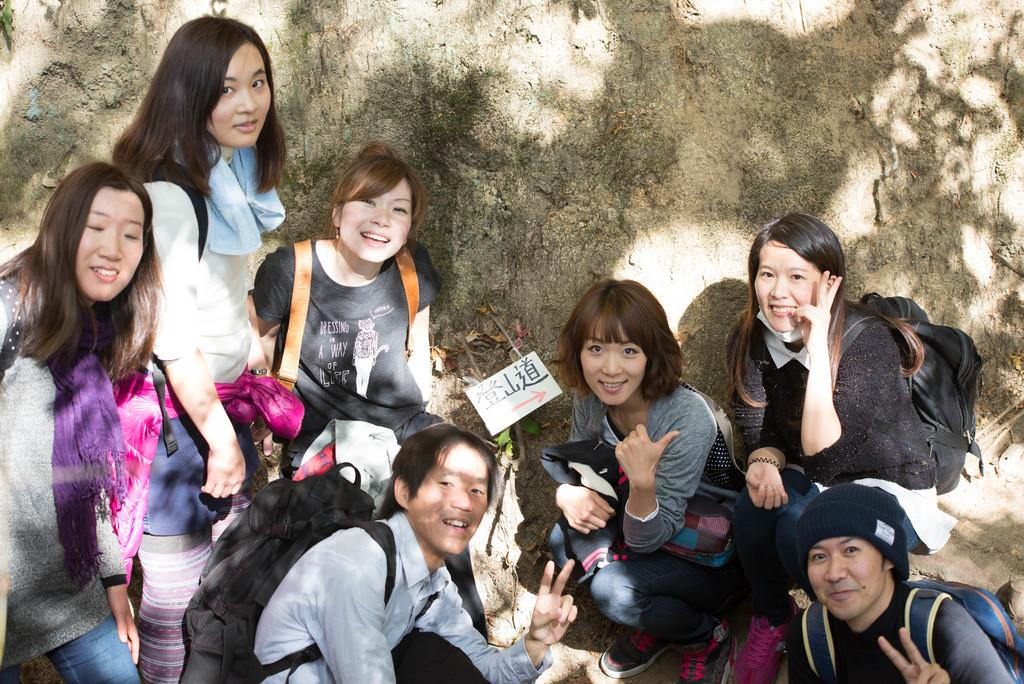What is the main subject of the image? There is a group of girls in the image. What are the girls doing in the image? The girls are posing for a picture. What can be seen in the background of the image? There is a big rock in the background of the image. What are the girls wearing that might be used for carrying items? The girls are wearing bags. What is present on the wall in the background of the image? There is a sticker on the wall in the background of the image. Can you tell me how many earths can fit inside the balls the girls are holding in the image? There are no balls present in the image, so it is not possible to determine how many earths could fit inside them. 